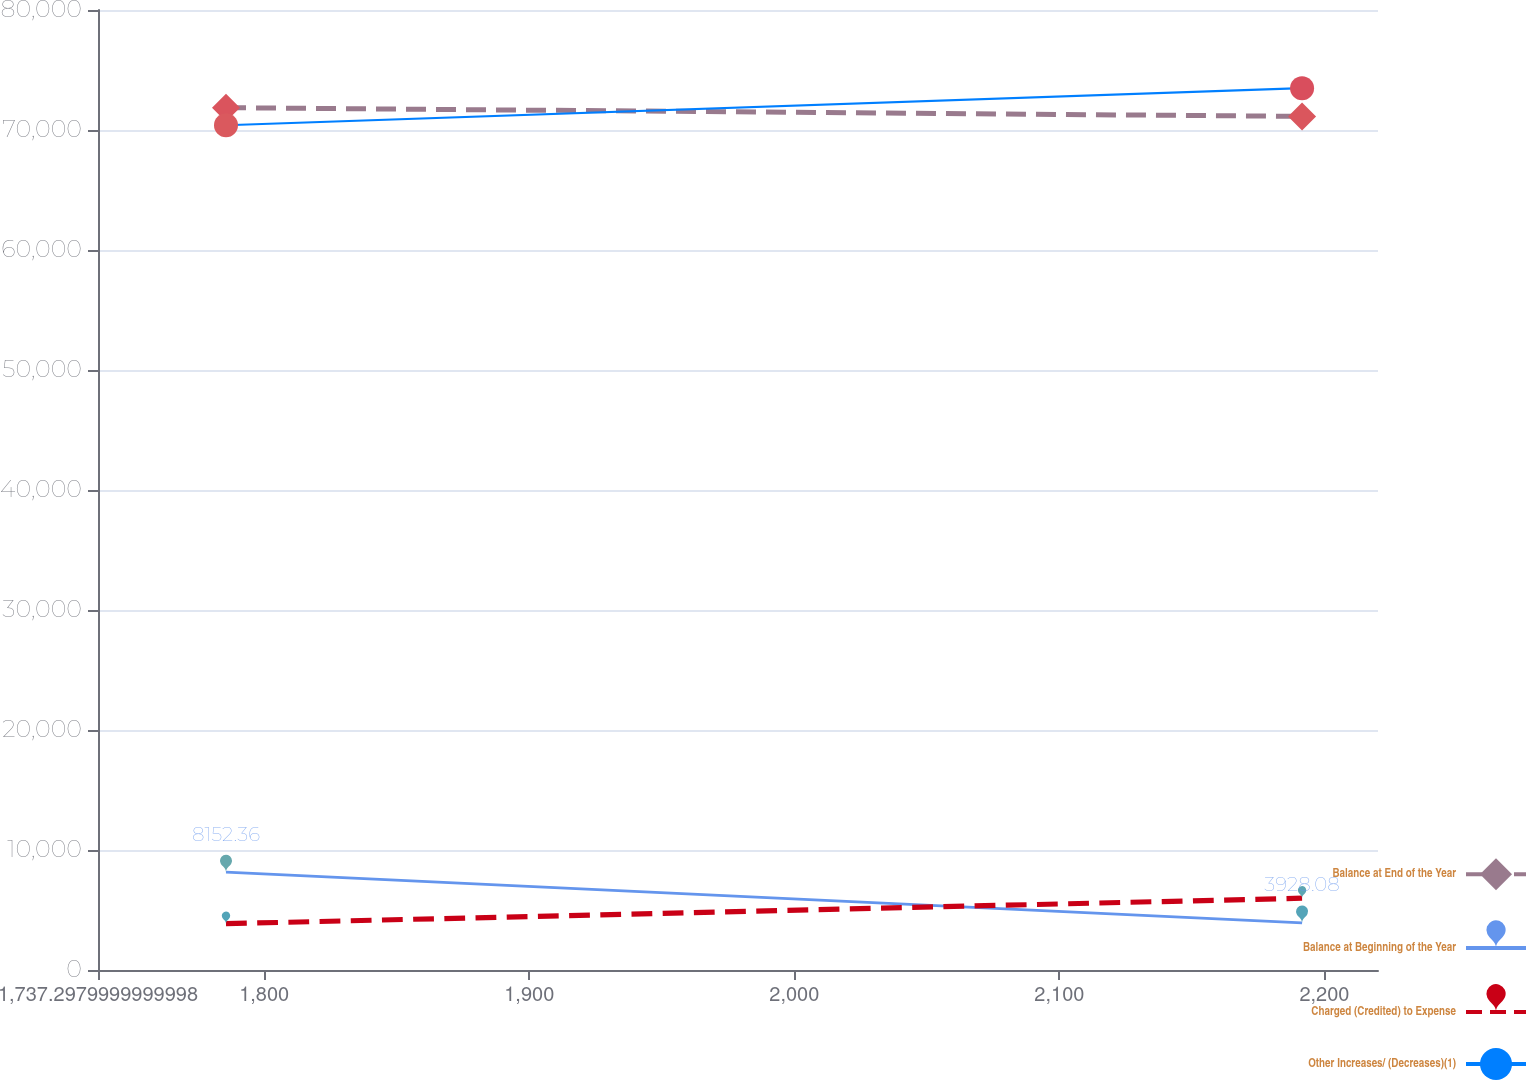Convert chart to OTSL. <chart><loc_0><loc_0><loc_500><loc_500><line_chart><ecel><fcel>Balance at End of the Year<fcel>Balance at Beginning of the Year<fcel>Charged (Credited) to Expense<fcel>Other Increases/ (Decreases)(1)<nl><fcel>1785.59<fcel>71857.6<fcel>8152.36<fcel>3857.35<fcel>70396.2<nl><fcel>2191.57<fcel>71135<fcel>3928.08<fcel>5983.42<fcel>73482.3<nl><fcel>2268.51<fcel>67218.8<fcel>3075.8<fcel>10077.2<fcel>56416.1<nl></chart> 